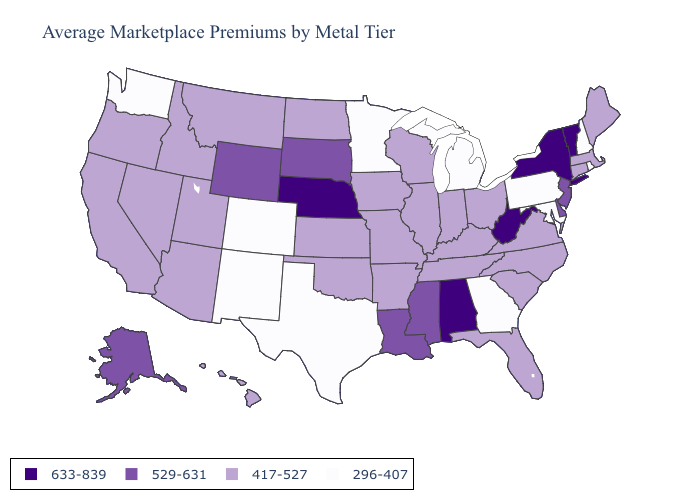Name the states that have a value in the range 633-839?
Concise answer only. Alabama, Nebraska, New York, Vermont, West Virginia. What is the value of Tennessee?
Write a very short answer. 417-527. Does Texas have the lowest value in the USA?
Answer briefly. Yes. Does the map have missing data?
Concise answer only. No. Does Idaho have a higher value than Georgia?
Be succinct. Yes. What is the lowest value in the USA?
Short answer required. 296-407. Does Alaska have the same value as Delaware?
Answer briefly. Yes. Among the states that border Michigan , which have the lowest value?
Be succinct. Indiana, Ohio, Wisconsin. What is the value of Pennsylvania?
Quick response, please. 296-407. What is the value of California?
Keep it brief. 417-527. Does Arkansas have the same value as Michigan?
Be succinct. No. Does the map have missing data?
Concise answer only. No. How many symbols are there in the legend?
Keep it brief. 4. Does Alabama have a higher value than West Virginia?
Write a very short answer. No. Does Ohio have the highest value in the USA?
Short answer required. No. 